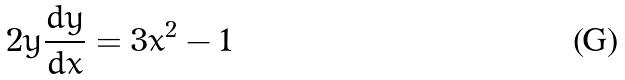<formula> <loc_0><loc_0><loc_500><loc_500>2 y \frac { d y } { d x } = 3 x ^ { 2 } - 1</formula> 